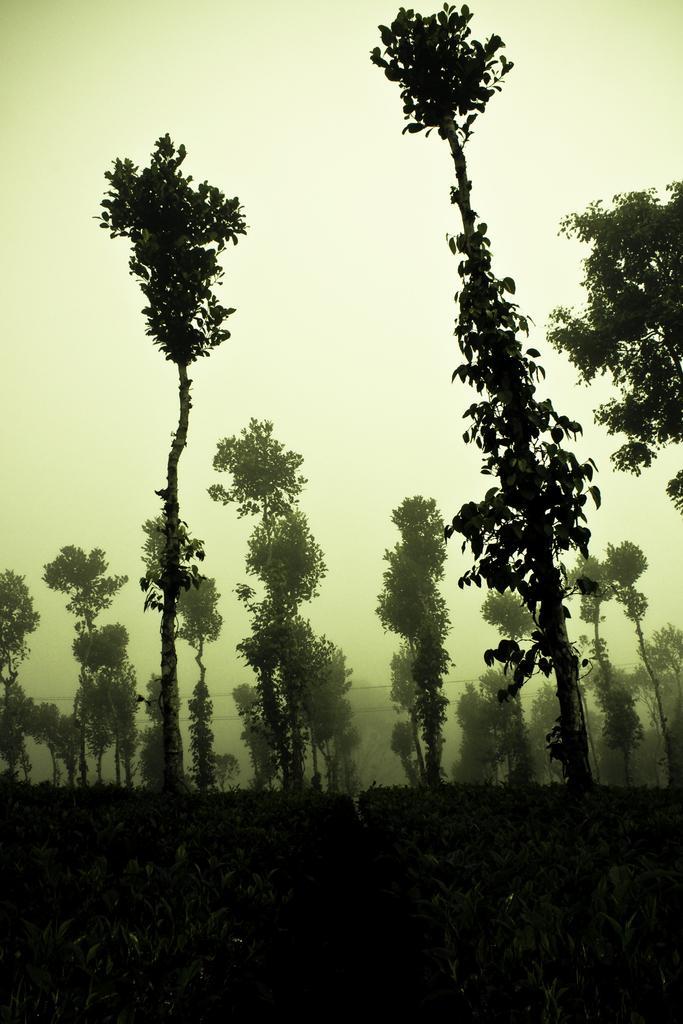Please provide a concise description of this image. In the image there are trees and plants on the land and above its sky. 